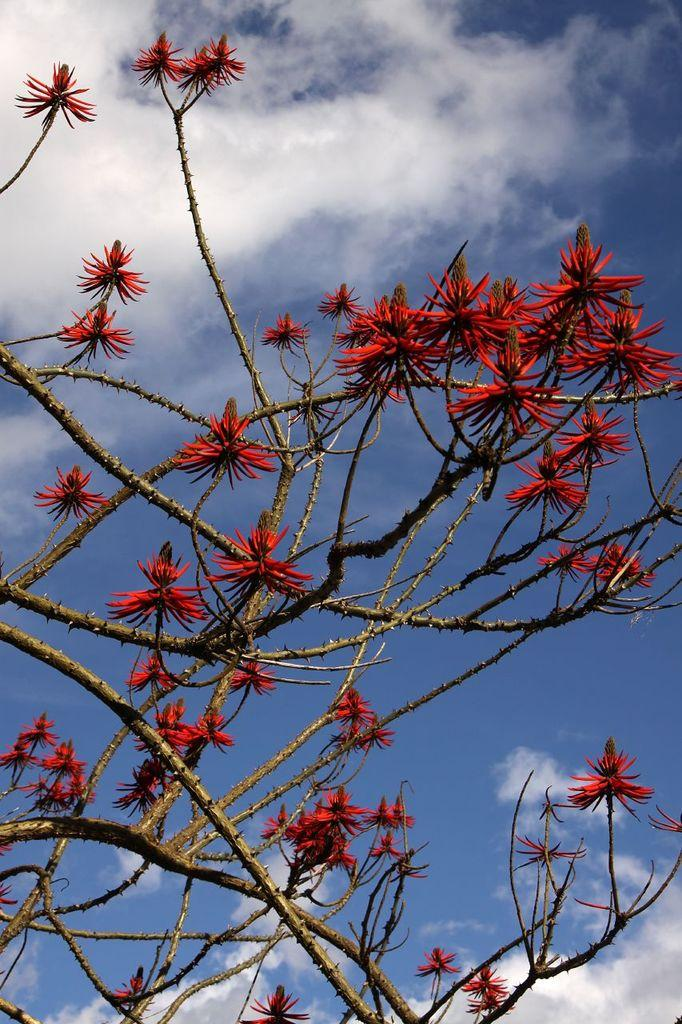What can be seen in the foreground of the picture? There are flowers and stems in the foreground of the picture. What is the condition of the sky in the picture? The sky is sunny in the picture. How many rings can be seen on the roof in the image? There is no roof or rings present in the image; it features flowers and stems in the foreground and a sunny sky. 